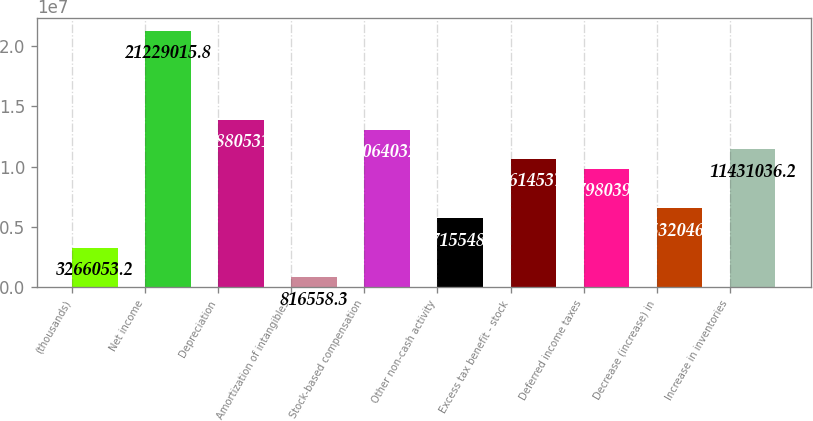Convert chart. <chart><loc_0><loc_0><loc_500><loc_500><bar_chart><fcel>(thousands)<fcel>Net income<fcel>Depreciation<fcel>Amortization of intangibles<fcel>Stock-based compensation<fcel>Other non-cash activity<fcel>Excess tax benefit - stock<fcel>Deferred income taxes<fcel>Decrease (increase) in<fcel>Increase in inventories<nl><fcel>3.26605e+06<fcel>2.1229e+07<fcel>1.38805e+07<fcel>816558<fcel>1.3064e+07<fcel>5.71555e+06<fcel>1.06145e+07<fcel>9.79804e+06<fcel>6.53205e+06<fcel>1.1431e+07<nl></chart> 